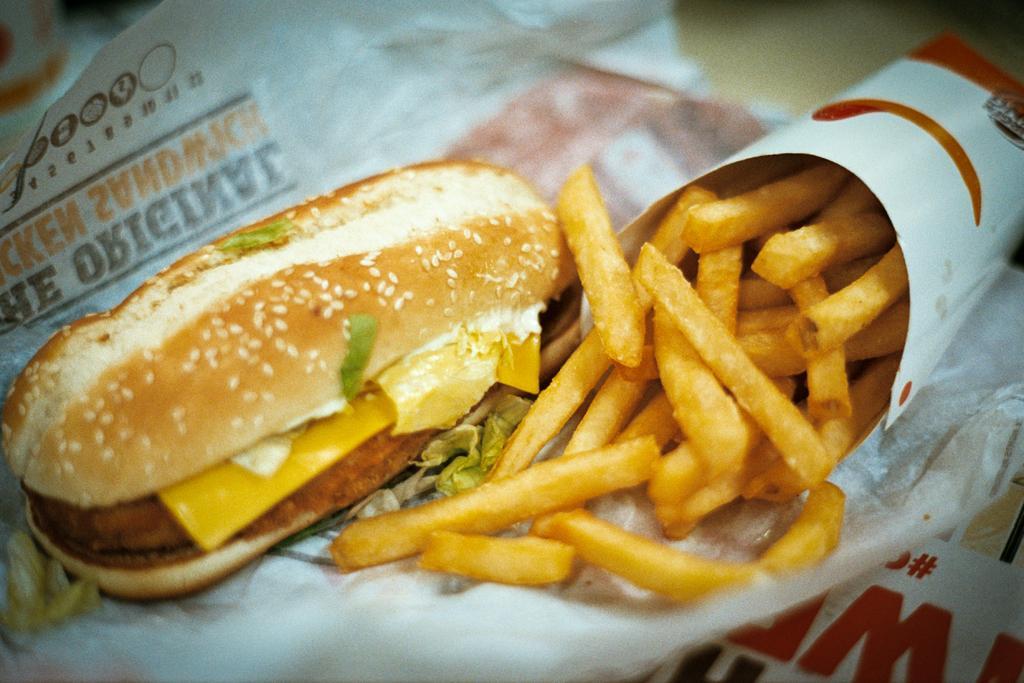How would you summarize this image in a sentence or two? In this image I can see the french-fries in the paper-cone and the burger on the paper. These are on the cream color surface. 